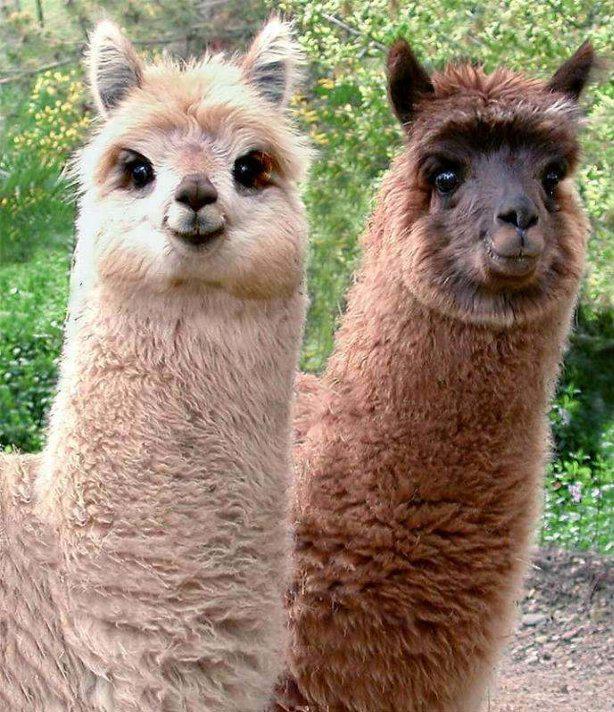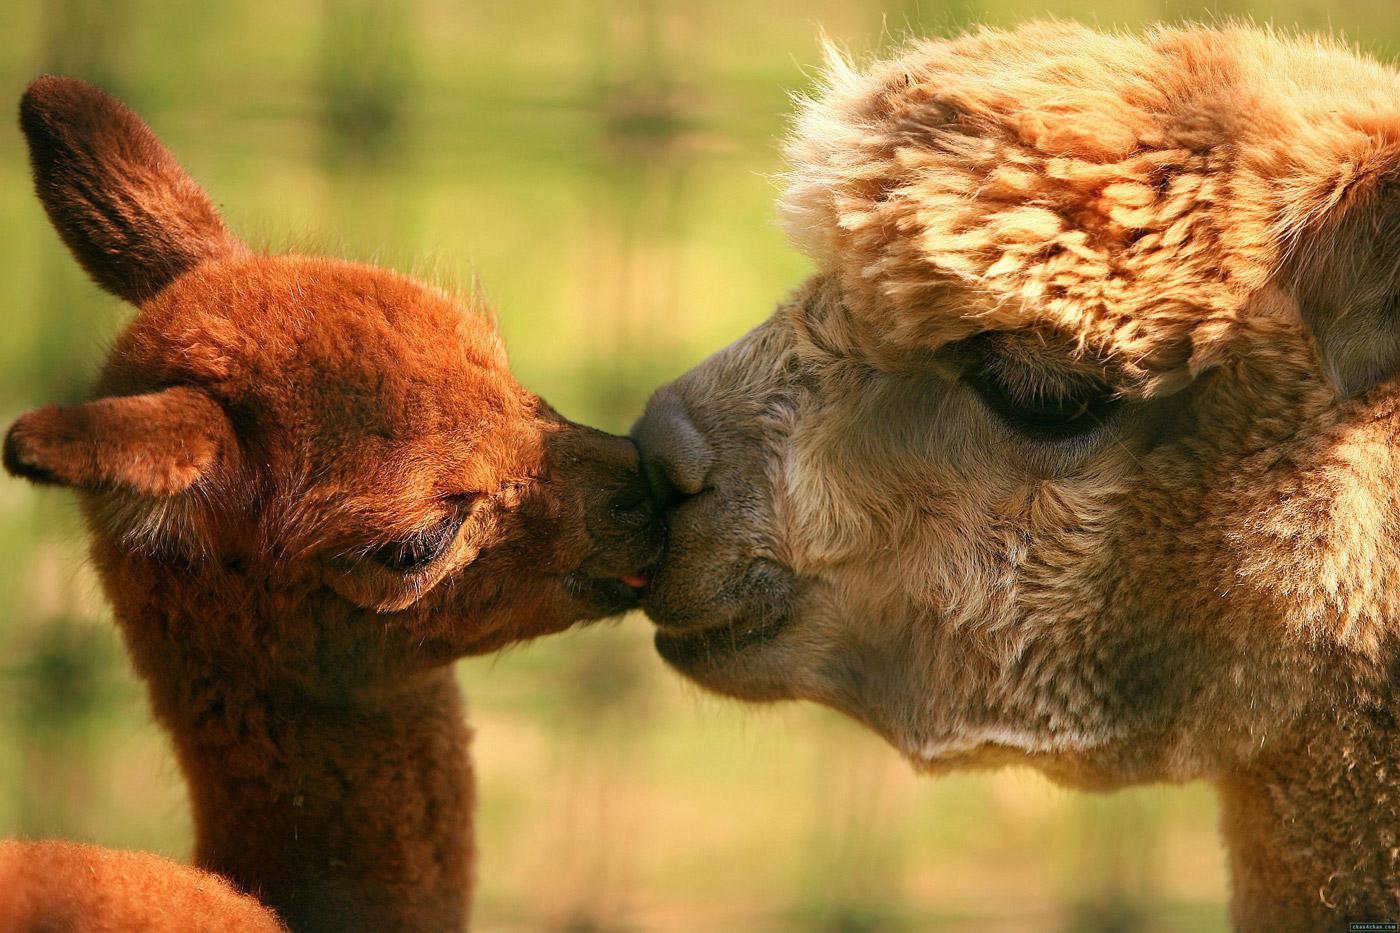The first image is the image on the left, the second image is the image on the right. Evaluate the accuracy of this statement regarding the images: "The left and right image contains a total of four llamas.". Is it true? Answer yes or no. Yes. The first image is the image on the left, the second image is the image on the right. For the images shown, is this caption "An image shows two llamas, with the mouth of the one on the left touching the face of the one on the right." true? Answer yes or no. Yes. 